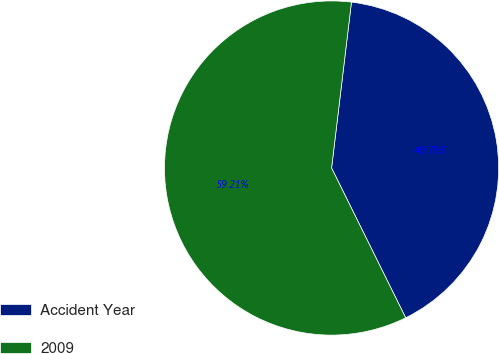Convert chart to OTSL. <chart><loc_0><loc_0><loc_500><loc_500><pie_chart><fcel>Accident Year<fcel>2009<nl><fcel>40.79%<fcel>59.21%<nl></chart> 